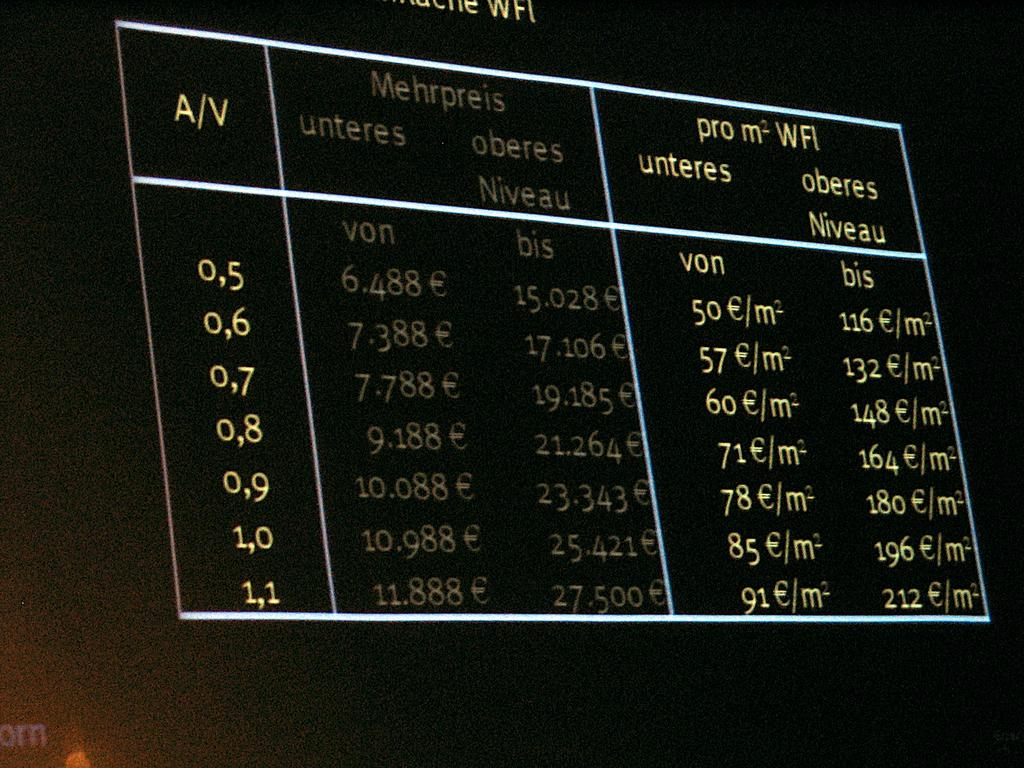<image>
Give a short and clear explanation of the subsequent image. Large black screen with the word MEHRPREIS on top. 